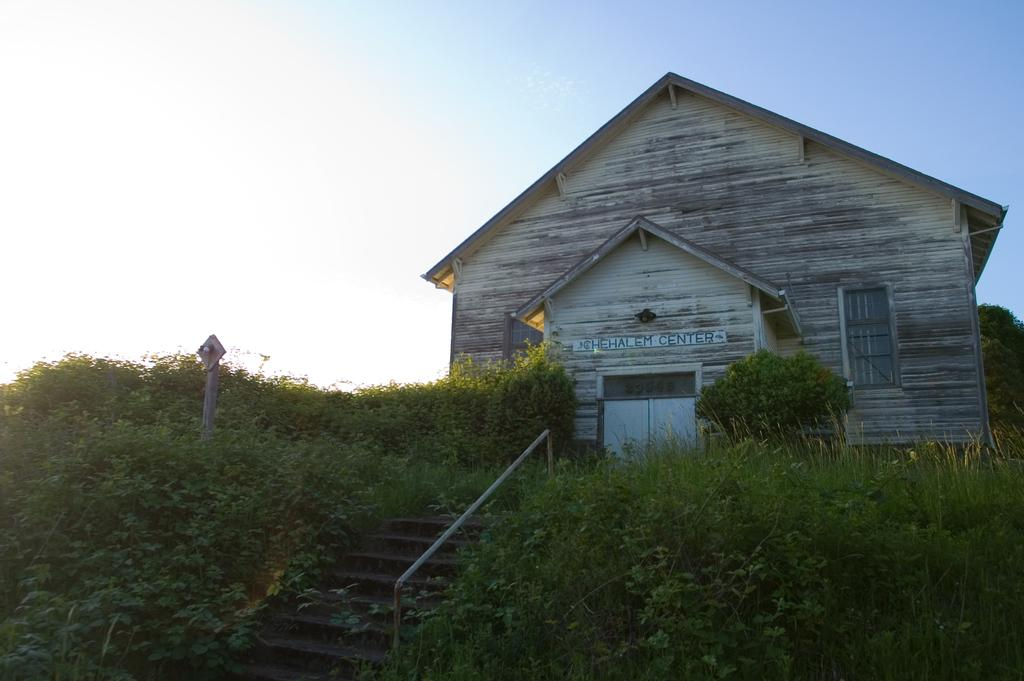What type of structure is present in the image? There is a building in the picture. Are there any architectural features visible in the image? Yes, there are stairs in the picture. How are the stairs decorated or covered? The stairs are covered with plants. What is the condition of the sky in the image? The sky is clear in the image. Can you tell me how many dolls are sitting on the partner's lap in the image? There is no partner or dolls present in the image. What type of dad can be seen interacting with the dolls in the image? There is no dad or dolls present in the image. 